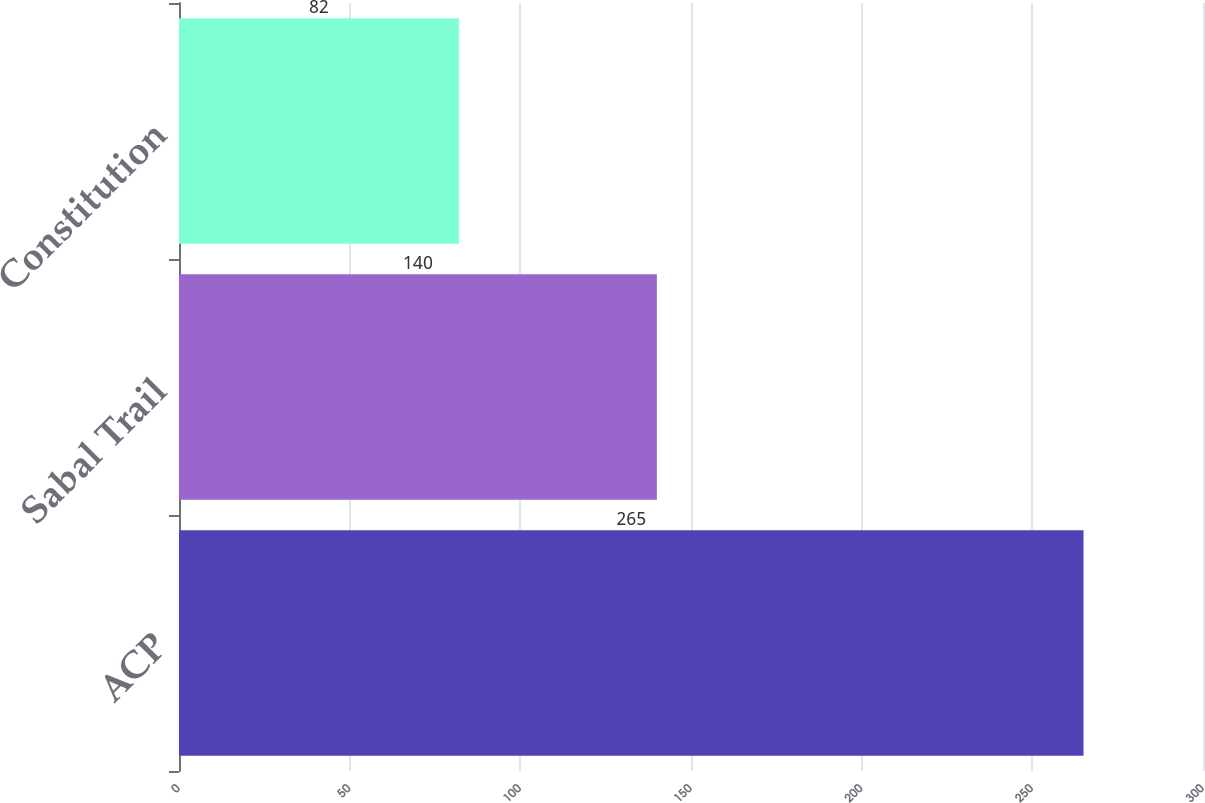<chart> <loc_0><loc_0><loc_500><loc_500><bar_chart><fcel>ACP<fcel>Sabal Trail<fcel>Constitution<nl><fcel>265<fcel>140<fcel>82<nl></chart> 